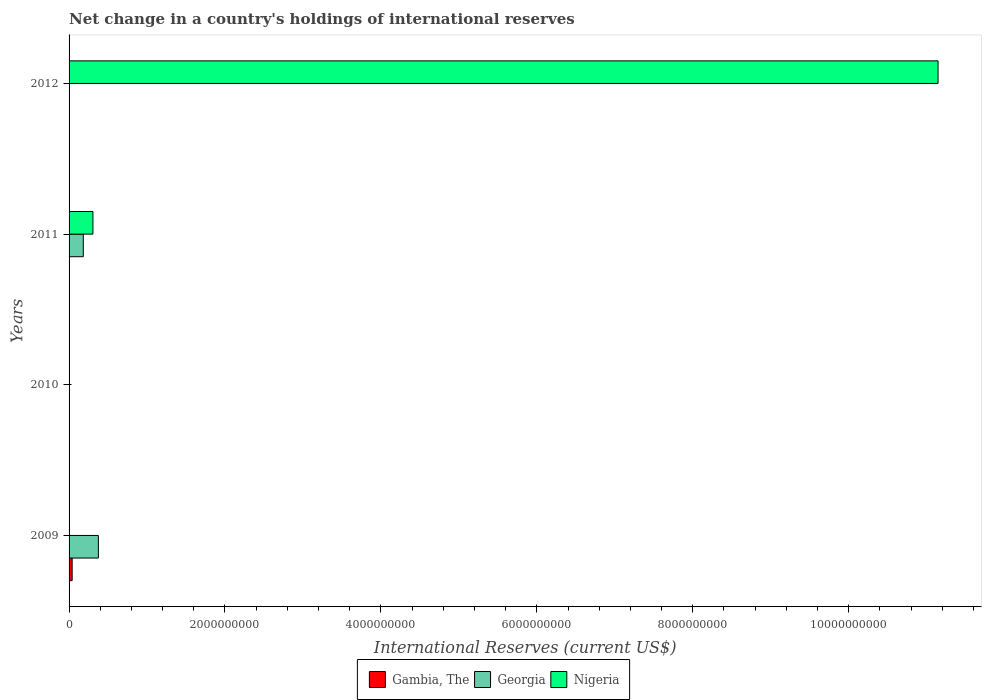Are the number of bars on each tick of the Y-axis equal?
Provide a short and direct response. No. How many bars are there on the 1st tick from the top?
Ensure brevity in your answer.  1. What is the international reserves in Gambia, The in 2009?
Your answer should be very brief. 3.96e+07. Across all years, what is the maximum international reserves in Nigeria?
Your answer should be very brief. 1.11e+1. What is the total international reserves in Nigeria in the graph?
Your response must be concise. 1.15e+1. What is the difference between the international reserves in Nigeria in 2010 and the international reserves in Georgia in 2009?
Provide a short and direct response. -3.76e+08. What is the average international reserves in Gambia, The per year?
Ensure brevity in your answer.  9.90e+06. In the year 2009, what is the difference between the international reserves in Gambia, The and international reserves in Georgia?
Your response must be concise. -3.36e+08. In how many years, is the international reserves in Nigeria greater than 1600000000 US$?
Offer a terse response. 1. What is the difference between the highest and the lowest international reserves in Georgia?
Keep it short and to the point. 3.76e+08. Are all the bars in the graph horizontal?
Your response must be concise. Yes. What is the difference between two consecutive major ticks on the X-axis?
Offer a terse response. 2.00e+09. Are the values on the major ticks of X-axis written in scientific E-notation?
Your answer should be compact. No. Does the graph contain any zero values?
Provide a short and direct response. Yes. Does the graph contain grids?
Offer a terse response. No. What is the title of the graph?
Provide a succinct answer. Net change in a country's holdings of international reserves. Does "Madagascar" appear as one of the legend labels in the graph?
Your response must be concise. No. What is the label or title of the X-axis?
Your response must be concise. International Reserves (current US$). What is the label or title of the Y-axis?
Your response must be concise. Years. What is the International Reserves (current US$) in Gambia, The in 2009?
Ensure brevity in your answer.  3.96e+07. What is the International Reserves (current US$) of Georgia in 2009?
Keep it short and to the point. 3.76e+08. What is the International Reserves (current US$) in Nigeria in 2009?
Your response must be concise. 0. What is the International Reserves (current US$) in Gambia, The in 2010?
Offer a terse response. 0. What is the International Reserves (current US$) in Georgia in 2010?
Offer a terse response. 0. What is the International Reserves (current US$) of Gambia, The in 2011?
Offer a very short reply. 0. What is the International Reserves (current US$) of Georgia in 2011?
Your answer should be very brief. 1.82e+08. What is the International Reserves (current US$) of Nigeria in 2011?
Offer a terse response. 3.06e+08. What is the International Reserves (current US$) in Georgia in 2012?
Your response must be concise. 0. What is the International Reserves (current US$) of Nigeria in 2012?
Make the answer very short. 1.11e+1. Across all years, what is the maximum International Reserves (current US$) of Gambia, The?
Provide a short and direct response. 3.96e+07. Across all years, what is the maximum International Reserves (current US$) in Georgia?
Give a very brief answer. 3.76e+08. Across all years, what is the maximum International Reserves (current US$) of Nigeria?
Offer a terse response. 1.11e+1. What is the total International Reserves (current US$) of Gambia, The in the graph?
Ensure brevity in your answer.  3.96e+07. What is the total International Reserves (current US$) of Georgia in the graph?
Offer a terse response. 5.58e+08. What is the total International Reserves (current US$) of Nigeria in the graph?
Your response must be concise. 1.15e+1. What is the difference between the International Reserves (current US$) in Georgia in 2009 and that in 2011?
Make the answer very short. 1.93e+08. What is the difference between the International Reserves (current US$) in Nigeria in 2011 and that in 2012?
Ensure brevity in your answer.  -1.08e+1. What is the difference between the International Reserves (current US$) of Gambia, The in 2009 and the International Reserves (current US$) of Georgia in 2011?
Your answer should be compact. -1.43e+08. What is the difference between the International Reserves (current US$) of Gambia, The in 2009 and the International Reserves (current US$) of Nigeria in 2011?
Ensure brevity in your answer.  -2.66e+08. What is the difference between the International Reserves (current US$) in Georgia in 2009 and the International Reserves (current US$) in Nigeria in 2011?
Give a very brief answer. 7.01e+07. What is the difference between the International Reserves (current US$) in Gambia, The in 2009 and the International Reserves (current US$) in Nigeria in 2012?
Give a very brief answer. -1.11e+1. What is the difference between the International Reserves (current US$) of Georgia in 2009 and the International Reserves (current US$) of Nigeria in 2012?
Offer a very short reply. -1.08e+1. What is the difference between the International Reserves (current US$) of Georgia in 2011 and the International Reserves (current US$) of Nigeria in 2012?
Your response must be concise. -1.10e+1. What is the average International Reserves (current US$) in Gambia, The per year?
Give a very brief answer. 9.90e+06. What is the average International Reserves (current US$) in Georgia per year?
Offer a terse response. 1.40e+08. What is the average International Reserves (current US$) of Nigeria per year?
Keep it short and to the point. 2.86e+09. In the year 2009, what is the difference between the International Reserves (current US$) of Gambia, The and International Reserves (current US$) of Georgia?
Offer a very short reply. -3.36e+08. In the year 2011, what is the difference between the International Reserves (current US$) of Georgia and International Reserves (current US$) of Nigeria?
Make the answer very short. -1.23e+08. What is the ratio of the International Reserves (current US$) in Georgia in 2009 to that in 2011?
Your answer should be very brief. 2.06. What is the ratio of the International Reserves (current US$) of Nigeria in 2011 to that in 2012?
Provide a short and direct response. 0.03. What is the difference between the highest and the lowest International Reserves (current US$) in Gambia, The?
Ensure brevity in your answer.  3.96e+07. What is the difference between the highest and the lowest International Reserves (current US$) in Georgia?
Keep it short and to the point. 3.76e+08. What is the difference between the highest and the lowest International Reserves (current US$) in Nigeria?
Offer a very short reply. 1.11e+1. 